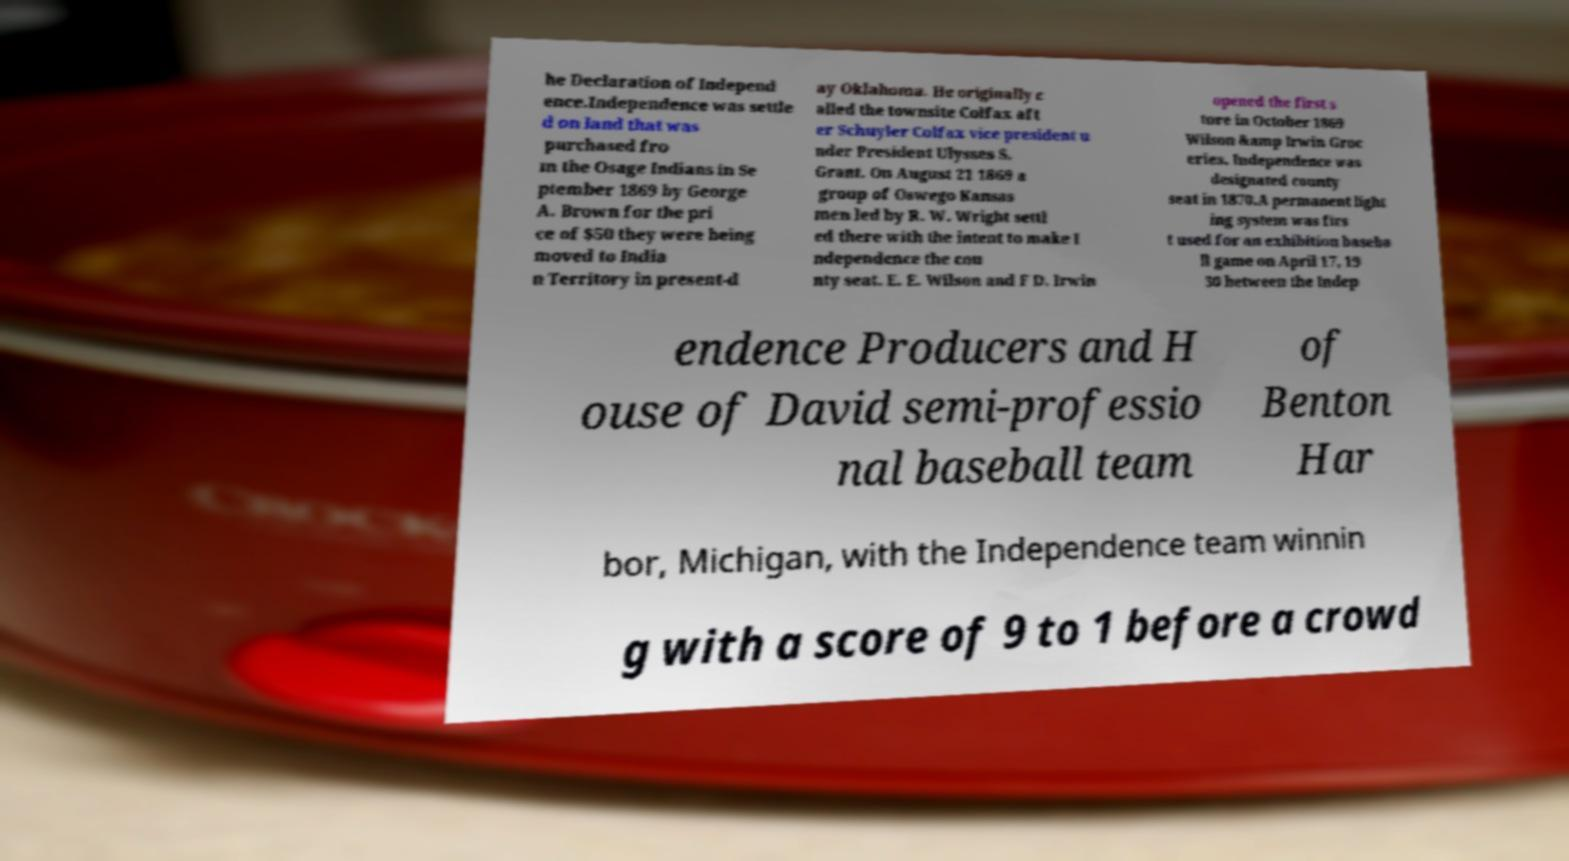Please read and relay the text visible in this image. What does it say? he Declaration of Independ ence.Independence was settle d on land that was purchased fro m the Osage Indians in Se ptember 1869 by George A. Brown for the pri ce of $50 they were being moved to India n Territory in present-d ay Oklahoma. He originally c alled the townsite Colfax aft er Schuyler Colfax vice president u nder President Ulysses S. Grant. On August 21 1869 a group of Oswego Kansas men led by R. W. Wright settl ed there with the intent to make I ndependence the cou nty seat. E. E. Wilson and F D. Irwin opened the first s tore in October 1869 Wilson &amp Irwin Groc eries. Independence was designated county seat in 1870.A permanent light ing system was firs t used for an exhibition baseba ll game on April 17, 19 30 between the Indep endence Producers and H ouse of David semi-professio nal baseball team of Benton Har bor, Michigan, with the Independence team winnin g with a score of 9 to 1 before a crowd 